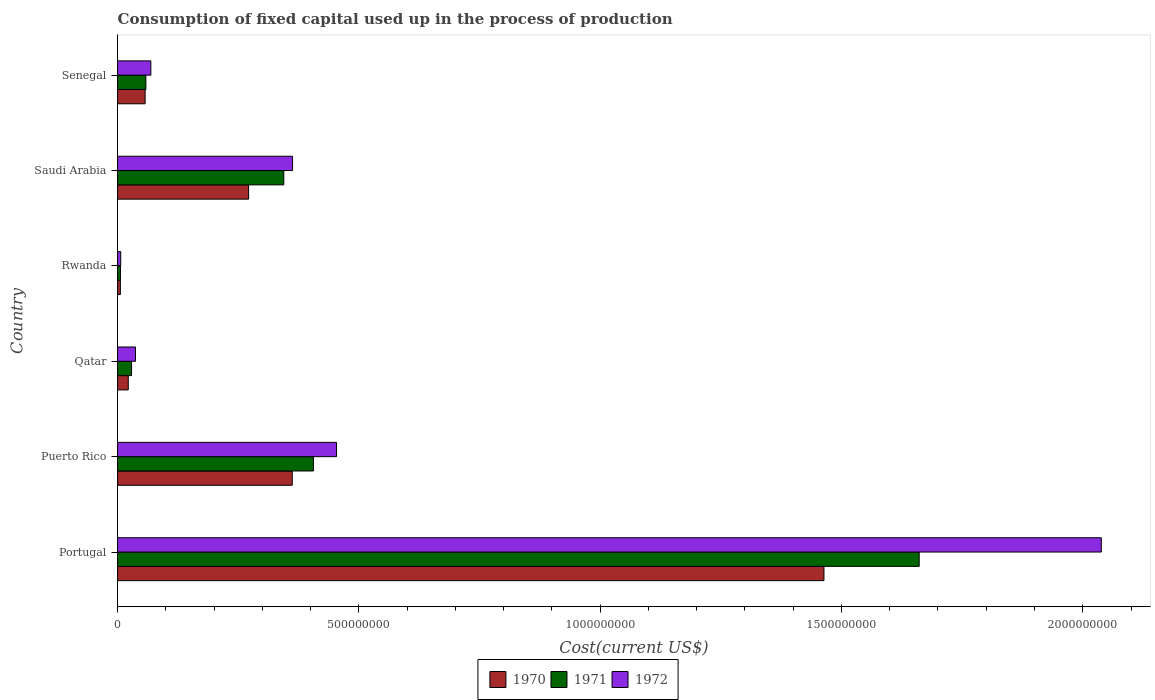Are the number of bars per tick equal to the number of legend labels?
Ensure brevity in your answer.  Yes. Are the number of bars on each tick of the Y-axis equal?
Offer a terse response. Yes. How many bars are there on the 5th tick from the bottom?
Provide a succinct answer. 3. What is the amount consumed in the process of production in 1970 in Rwanda?
Provide a short and direct response. 5.84e+06. Across all countries, what is the maximum amount consumed in the process of production in 1972?
Make the answer very short. 2.04e+09. Across all countries, what is the minimum amount consumed in the process of production in 1970?
Your response must be concise. 5.84e+06. In which country was the amount consumed in the process of production in 1971 maximum?
Your answer should be very brief. Portugal. In which country was the amount consumed in the process of production in 1972 minimum?
Provide a short and direct response. Rwanda. What is the total amount consumed in the process of production in 1971 in the graph?
Your answer should be very brief. 2.51e+09. What is the difference between the amount consumed in the process of production in 1971 in Puerto Rico and that in Qatar?
Make the answer very short. 3.77e+08. What is the difference between the amount consumed in the process of production in 1971 in Saudi Arabia and the amount consumed in the process of production in 1970 in Puerto Rico?
Offer a terse response. -1.75e+07. What is the average amount consumed in the process of production in 1972 per country?
Your answer should be compact. 4.95e+08. What is the difference between the amount consumed in the process of production in 1971 and amount consumed in the process of production in 1972 in Rwanda?
Keep it short and to the point. -5.68e+05. What is the ratio of the amount consumed in the process of production in 1971 in Saudi Arabia to that in Senegal?
Give a very brief answer. 5.87. What is the difference between the highest and the second highest amount consumed in the process of production in 1971?
Offer a terse response. 1.26e+09. What is the difference between the highest and the lowest amount consumed in the process of production in 1971?
Your answer should be compact. 1.66e+09. What does the 1st bar from the top in Qatar represents?
Make the answer very short. 1972. What does the 2nd bar from the bottom in Puerto Rico represents?
Your response must be concise. 1971. How many bars are there?
Provide a succinct answer. 18. How many countries are there in the graph?
Make the answer very short. 6. Are the values on the major ticks of X-axis written in scientific E-notation?
Your response must be concise. No. Does the graph contain grids?
Your response must be concise. No. How many legend labels are there?
Your answer should be compact. 3. What is the title of the graph?
Make the answer very short. Consumption of fixed capital used up in the process of production. Does "1972" appear as one of the legend labels in the graph?
Offer a very short reply. Yes. What is the label or title of the X-axis?
Ensure brevity in your answer.  Cost(current US$). What is the label or title of the Y-axis?
Your answer should be very brief. Country. What is the Cost(current US$) of 1970 in Portugal?
Offer a very short reply. 1.46e+09. What is the Cost(current US$) of 1971 in Portugal?
Your answer should be very brief. 1.66e+09. What is the Cost(current US$) in 1972 in Portugal?
Make the answer very short. 2.04e+09. What is the Cost(current US$) in 1970 in Puerto Rico?
Make the answer very short. 3.62e+08. What is the Cost(current US$) in 1971 in Puerto Rico?
Provide a succinct answer. 4.06e+08. What is the Cost(current US$) in 1972 in Puerto Rico?
Keep it short and to the point. 4.54e+08. What is the Cost(current US$) of 1970 in Qatar?
Ensure brevity in your answer.  2.22e+07. What is the Cost(current US$) in 1971 in Qatar?
Your response must be concise. 2.90e+07. What is the Cost(current US$) of 1972 in Qatar?
Provide a succinct answer. 3.72e+07. What is the Cost(current US$) of 1970 in Rwanda?
Your response must be concise. 5.84e+06. What is the Cost(current US$) of 1971 in Rwanda?
Your answer should be very brief. 5.99e+06. What is the Cost(current US$) of 1972 in Rwanda?
Provide a succinct answer. 6.56e+06. What is the Cost(current US$) in 1970 in Saudi Arabia?
Ensure brevity in your answer.  2.72e+08. What is the Cost(current US$) of 1971 in Saudi Arabia?
Offer a terse response. 3.44e+08. What is the Cost(current US$) in 1972 in Saudi Arabia?
Your answer should be compact. 3.63e+08. What is the Cost(current US$) in 1970 in Senegal?
Keep it short and to the point. 5.71e+07. What is the Cost(current US$) in 1971 in Senegal?
Offer a very short reply. 5.87e+07. What is the Cost(current US$) in 1972 in Senegal?
Provide a short and direct response. 6.90e+07. Across all countries, what is the maximum Cost(current US$) in 1970?
Give a very brief answer. 1.46e+09. Across all countries, what is the maximum Cost(current US$) in 1971?
Offer a terse response. 1.66e+09. Across all countries, what is the maximum Cost(current US$) of 1972?
Provide a succinct answer. 2.04e+09. Across all countries, what is the minimum Cost(current US$) in 1970?
Your answer should be very brief. 5.84e+06. Across all countries, what is the minimum Cost(current US$) of 1971?
Give a very brief answer. 5.99e+06. Across all countries, what is the minimum Cost(current US$) of 1972?
Your answer should be compact. 6.56e+06. What is the total Cost(current US$) of 1970 in the graph?
Make the answer very short. 2.18e+09. What is the total Cost(current US$) of 1971 in the graph?
Provide a succinct answer. 2.51e+09. What is the total Cost(current US$) of 1972 in the graph?
Provide a succinct answer. 2.97e+09. What is the difference between the Cost(current US$) in 1970 in Portugal and that in Puerto Rico?
Make the answer very short. 1.10e+09. What is the difference between the Cost(current US$) of 1971 in Portugal and that in Puerto Rico?
Keep it short and to the point. 1.26e+09. What is the difference between the Cost(current US$) of 1972 in Portugal and that in Puerto Rico?
Provide a succinct answer. 1.58e+09. What is the difference between the Cost(current US$) in 1970 in Portugal and that in Qatar?
Offer a terse response. 1.44e+09. What is the difference between the Cost(current US$) of 1971 in Portugal and that in Qatar?
Give a very brief answer. 1.63e+09. What is the difference between the Cost(current US$) of 1972 in Portugal and that in Qatar?
Offer a terse response. 2.00e+09. What is the difference between the Cost(current US$) in 1970 in Portugal and that in Rwanda?
Offer a terse response. 1.46e+09. What is the difference between the Cost(current US$) in 1971 in Portugal and that in Rwanda?
Provide a succinct answer. 1.66e+09. What is the difference between the Cost(current US$) of 1972 in Portugal and that in Rwanda?
Your response must be concise. 2.03e+09. What is the difference between the Cost(current US$) in 1970 in Portugal and that in Saudi Arabia?
Your response must be concise. 1.19e+09. What is the difference between the Cost(current US$) in 1971 in Portugal and that in Saudi Arabia?
Keep it short and to the point. 1.32e+09. What is the difference between the Cost(current US$) of 1972 in Portugal and that in Saudi Arabia?
Keep it short and to the point. 1.68e+09. What is the difference between the Cost(current US$) in 1970 in Portugal and that in Senegal?
Keep it short and to the point. 1.41e+09. What is the difference between the Cost(current US$) of 1971 in Portugal and that in Senegal?
Offer a very short reply. 1.60e+09. What is the difference between the Cost(current US$) of 1972 in Portugal and that in Senegal?
Keep it short and to the point. 1.97e+09. What is the difference between the Cost(current US$) of 1970 in Puerto Rico and that in Qatar?
Your answer should be very brief. 3.40e+08. What is the difference between the Cost(current US$) in 1971 in Puerto Rico and that in Qatar?
Provide a short and direct response. 3.77e+08. What is the difference between the Cost(current US$) in 1972 in Puerto Rico and that in Qatar?
Offer a terse response. 4.17e+08. What is the difference between the Cost(current US$) in 1970 in Puerto Rico and that in Rwanda?
Give a very brief answer. 3.56e+08. What is the difference between the Cost(current US$) in 1971 in Puerto Rico and that in Rwanda?
Ensure brevity in your answer.  4.00e+08. What is the difference between the Cost(current US$) of 1972 in Puerto Rico and that in Rwanda?
Keep it short and to the point. 4.47e+08. What is the difference between the Cost(current US$) of 1970 in Puerto Rico and that in Saudi Arabia?
Offer a very short reply. 9.04e+07. What is the difference between the Cost(current US$) of 1971 in Puerto Rico and that in Saudi Arabia?
Provide a short and direct response. 6.15e+07. What is the difference between the Cost(current US$) in 1972 in Puerto Rico and that in Saudi Arabia?
Provide a short and direct response. 9.11e+07. What is the difference between the Cost(current US$) of 1970 in Puerto Rico and that in Senegal?
Provide a succinct answer. 3.05e+08. What is the difference between the Cost(current US$) in 1971 in Puerto Rico and that in Senegal?
Offer a terse response. 3.47e+08. What is the difference between the Cost(current US$) in 1972 in Puerto Rico and that in Senegal?
Provide a succinct answer. 3.85e+08. What is the difference between the Cost(current US$) in 1970 in Qatar and that in Rwanda?
Provide a short and direct response. 1.63e+07. What is the difference between the Cost(current US$) in 1971 in Qatar and that in Rwanda?
Provide a succinct answer. 2.30e+07. What is the difference between the Cost(current US$) in 1972 in Qatar and that in Rwanda?
Ensure brevity in your answer.  3.06e+07. What is the difference between the Cost(current US$) in 1970 in Qatar and that in Saudi Arabia?
Make the answer very short. -2.49e+08. What is the difference between the Cost(current US$) of 1971 in Qatar and that in Saudi Arabia?
Your answer should be very brief. -3.15e+08. What is the difference between the Cost(current US$) of 1972 in Qatar and that in Saudi Arabia?
Provide a succinct answer. -3.25e+08. What is the difference between the Cost(current US$) in 1970 in Qatar and that in Senegal?
Make the answer very short. -3.50e+07. What is the difference between the Cost(current US$) of 1971 in Qatar and that in Senegal?
Your answer should be compact. -2.97e+07. What is the difference between the Cost(current US$) in 1972 in Qatar and that in Senegal?
Ensure brevity in your answer.  -3.18e+07. What is the difference between the Cost(current US$) in 1970 in Rwanda and that in Saudi Arabia?
Provide a succinct answer. -2.66e+08. What is the difference between the Cost(current US$) in 1971 in Rwanda and that in Saudi Arabia?
Make the answer very short. -3.38e+08. What is the difference between the Cost(current US$) of 1972 in Rwanda and that in Saudi Arabia?
Ensure brevity in your answer.  -3.56e+08. What is the difference between the Cost(current US$) in 1970 in Rwanda and that in Senegal?
Provide a succinct answer. -5.13e+07. What is the difference between the Cost(current US$) of 1971 in Rwanda and that in Senegal?
Make the answer very short. -5.27e+07. What is the difference between the Cost(current US$) in 1972 in Rwanda and that in Senegal?
Your response must be concise. -6.24e+07. What is the difference between the Cost(current US$) in 1970 in Saudi Arabia and that in Senegal?
Provide a short and direct response. 2.14e+08. What is the difference between the Cost(current US$) in 1971 in Saudi Arabia and that in Senegal?
Offer a terse response. 2.86e+08. What is the difference between the Cost(current US$) in 1972 in Saudi Arabia and that in Senegal?
Offer a very short reply. 2.94e+08. What is the difference between the Cost(current US$) of 1970 in Portugal and the Cost(current US$) of 1971 in Puerto Rico?
Make the answer very short. 1.06e+09. What is the difference between the Cost(current US$) in 1970 in Portugal and the Cost(current US$) in 1972 in Puerto Rico?
Provide a succinct answer. 1.01e+09. What is the difference between the Cost(current US$) of 1971 in Portugal and the Cost(current US$) of 1972 in Puerto Rico?
Your answer should be very brief. 1.21e+09. What is the difference between the Cost(current US$) of 1970 in Portugal and the Cost(current US$) of 1971 in Qatar?
Your answer should be very brief. 1.43e+09. What is the difference between the Cost(current US$) of 1970 in Portugal and the Cost(current US$) of 1972 in Qatar?
Your response must be concise. 1.43e+09. What is the difference between the Cost(current US$) in 1971 in Portugal and the Cost(current US$) in 1972 in Qatar?
Provide a succinct answer. 1.62e+09. What is the difference between the Cost(current US$) of 1970 in Portugal and the Cost(current US$) of 1971 in Rwanda?
Your answer should be compact. 1.46e+09. What is the difference between the Cost(current US$) in 1970 in Portugal and the Cost(current US$) in 1972 in Rwanda?
Offer a terse response. 1.46e+09. What is the difference between the Cost(current US$) in 1971 in Portugal and the Cost(current US$) in 1972 in Rwanda?
Offer a terse response. 1.65e+09. What is the difference between the Cost(current US$) in 1970 in Portugal and the Cost(current US$) in 1971 in Saudi Arabia?
Your answer should be compact. 1.12e+09. What is the difference between the Cost(current US$) of 1970 in Portugal and the Cost(current US$) of 1972 in Saudi Arabia?
Offer a very short reply. 1.10e+09. What is the difference between the Cost(current US$) in 1971 in Portugal and the Cost(current US$) in 1972 in Saudi Arabia?
Make the answer very short. 1.30e+09. What is the difference between the Cost(current US$) of 1970 in Portugal and the Cost(current US$) of 1971 in Senegal?
Offer a very short reply. 1.41e+09. What is the difference between the Cost(current US$) in 1970 in Portugal and the Cost(current US$) in 1972 in Senegal?
Offer a terse response. 1.39e+09. What is the difference between the Cost(current US$) in 1971 in Portugal and the Cost(current US$) in 1972 in Senegal?
Your answer should be very brief. 1.59e+09. What is the difference between the Cost(current US$) of 1970 in Puerto Rico and the Cost(current US$) of 1971 in Qatar?
Offer a very short reply. 3.33e+08. What is the difference between the Cost(current US$) in 1970 in Puerto Rico and the Cost(current US$) in 1972 in Qatar?
Your answer should be very brief. 3.25e+08. What is the difference between the Cost(current US$) of 1971 in Puerto Rico and the Cost(current US$) of 1972 in Qatar?
Offer a terse response. 3.69e+08. What is the difference between the Cost(current US$) in 1970 in Puerto Rico and the Cost(current US$) in 1971 in Rwanda?
Offer a terse response. 3.56e+08. What is the difference between the Cost(current US$) of 1970 in Puerto Rico and the Cost(current US$) of 1972 in Rwanda?
Keep it short and to the point. 3.55e+08. What is the difference between the Cost(current US$) in 1971 in Puerto Rico and the Cost(current US$) in 1972 in Rwanda?
Give a very brief answer. 3.99e+08. What is the difference between the Cost(current US$) of 1970 in Puerto Rico and the Cost(current US$) of 1971 in Saudi Arabia?
Provide a succinct answer. 1.75e+07. What is the difference between the Cost(current US$) in 1970 in Puerto Rico and the Cost(current US$) in 1972 in Saudi Arabia?
Make the answer very short. -6.36e+05. What is the difference between the Cost(current US$) of 1971 in Puerto Rico and the Cost(current US$) of 1972 in Saudi Arabia?
Your response must be concise. 4.33e+07. What is the difference between the Cost(current US$) of 1970 in Puerto Rico and the Cost(current US$) of 1971 in Senegal?
Make the answer very short. 3.03e+08. What is the difference between the Cost(current US$) in 1970 in Puerto Rico and the Cost(current US$) in 1972 in Senegal?
Your answer should be very brief. 2.93e+08. What is the difference between the Cost(current US$) of 1971 in Puerto Rico and the Cost(current US$) of 1972 in Senegal?
Keep it short and to the point. 3.37e+08. What is the difference between the Cost(current US$) of 1970 in Qatar and the Cost(current US$) of 1971 in Rwanda?
Give a very brief answer. 1.62e+07. What is the difference between the Cost(current US$) of 1970 in Qatar and the Cost(current US$) of 1972 in Rwanda?
Offer a terse response. 1.56e+07. What is the difference between the Cost(current US$) in 1971 in Qatar and the Cost(current US$) in 1972 in Rwanda?
Make the answer very short. 2.24e+07. What is the difference between the Cost(current US$) in 1970 in Qatar and the Cost(current US$) in 1971 in Saudi Arabia?
Your answer should be very brief. -3.22e+08. What is the difference between the Cost(current US$) of 1970 in Qatar and the Cost(current US$) of 1972 in Saudi Arabia?
Offer a very short reply. -3.40e+08. What is the difference between the Cost(current US$) in 1971 in Qatar and the Cost(current US$) in 1972 in Saudi Arabia?
Make the answer very short. -3.34e+08. What is the difference between the Cost(current US$) in 1970 in Qatar and the Cost(current US$) in 1971 in Senegal?
Provide a short and direct response. -3.65e+07. What is the difference between the Cost(current US$) of 1970 in Qatar and the Cost(current US$) of 1972 in Senegal?
Your response must be concise. -4.68e+07. What is the difference between the Cost(current US$) in 1971 in Qatar and the Cost(current US$) in 1972 in Senegal?
Give a very brief answer. -4.00e+07. What is the difference between the Cost(current US$) of 1970 in Rwanda and the Cost(current US$) of 1971 in Saudi Arabia?
Make the answer very short. -3.39e+08. What is the difference between the Cost(current US$) in 1970 in Rwanda and the Cost(current US$) in 1972 in Saudi Arabia?
Provide a short and direct response. -3.57e+08. What is the difference between the Cost(current US$) in 1971 in Rwanda and the Cost(current US$) in 1972 in Saudi Arabia?
Your answer should be very brief. -3.57e+08. What is the difference between the Cost(current US$) of 1970 in Rwanda and the Cost(current US$) of 1971 in Senegal?
Give a very brief answer. -5.29e+07. What is the difference between the Cost(current US$) in 1970 in Rwanda and the Cost(current US$) in 1972 in Senegal?
Your answer should be compact. -6.31e+07. What is the difference between the Cost(current US$) of 1971 in Rwanda and the Cost(current US$) of 1972 in Senegal?
Provide a succinct answer. -6.30e+07. What is the difference between the Cost(current US$) in 1970 in Saudi Arabia and the Cost(current US$) in 1971 in Senegal?
Give a very brief answer. 2.13e+08. What is the difference between the Cost(current US$) of 1970 in Saudi Arabia and the Cost(current US$) of 1972 in Senegal?
Ensure brevity in your answer.  2.03e+08. What is the difference between the Cost(current US$) in 1971 in Saudi Arabia and the Cost(current US$) in 1972 in Senegal?
Offer a terse response. 2.75e+08. What is the average Cost(current US$) of 1970 per country?
Your response must be concise. 3.64e+08. What is the average Cost(current US$) in 1971 per country?
Your response must be concise. 4.18e+08. What is the average Cost(current US$) in 1972 per country?
Ensure brevity in your answer.  4.95e+08. What is the difference between the Cost(current US$) in 1970 and Cost(current US$) in 1971 in Portugal?
Your response must be concise. -1.97e+08. What is the difference between the Cost(current US$) of 1970 and Cost(current US$) of 1972 in Portugal?
Provide a short and direct response. -5.75e+08. What is the difference between the Cost(current US$) in 1971 and Cost(current US$) in 1972 in Portugal?
Provide a short and direct response. -3.77e+08. What is the difference between the Cost(current US$) in 1970 and Cost(current US$) in 1971 in Puerto Rico?
Make the answer very short. -4.40e+07. What is the difference between the Cost(current US$) of 1970 and Cost(current US$) of 1972 in Puerto Rico?
Make the answer very short. -9.18e+07. What is the difference between the Cost(current US$) in 1971 and Cost(current US$) in 1972 in Puerto Rico?
Your answer should be compact. -4.78e+07. What is the difference between the Cost(current US$) of 1970 and Cost(current US$) of 1971 in Qatar?
Keep it short and to the point. -6.81e+06. What is the difference between the Cost(current US$) in 1970 and Cost(current US$) in 1972 in Qatar?
Your response must be concise. -1.50e+07. What is the difference between the Cost(current US$) of 1971 and Cost(current US$) of 1972 in Qatar?
Provide a short and direct response. -8.20e+06. What is the difference between the Cost(current US$) of 1970 and Cost(current US$) of 1971 in Rwanda?
Make the answer very short. -1.47e+05. What is the difference between the Cost(current US$) in 1970 and Cost(current US$) in 1972 in Rwanda?
Your answer should be very brief. -7.15e+05. What is the difference between the Cost(current US$) in 1971 and Cost(current US$) in 1972 in Rwanda?
Provide a short and direct response. -5.68e+05. What is the difference between the Cost(current US$) in 1970 and Cost(current US$) in 1971 in Saudi Arabia?
Provide a succinct answer. -7.29e+07. What is the difference between the Cost(current US$) in 1970 and Cost(current US$) in 1972 in Saudi Arabia?
Your answer should be compact. -9.11e+07. What is the difference between the Cost(current US$) of 1971 and Cost(current US$) of 1972 in Saudi Arabia?
Offer a very short reply. -1.81e+07. What is the difference between the Cost(current US$) of 1970 and Cost(current US$) of 1971 in Senegal?
Keep it short and to the point. -1.55e+06. What is the difference between the Cost(current US$) of 1970 and Cost(current US$) of 1972 in Senegal?
Offer a very short reply. -1.18e+07. What is the difference between the Cost(current US$) in 1971 and Cost(current US$) in 1972 in Senegal?
Keep it short and to the point. -1.03e+07. What is the ratio of the Cost(current US$) of 1970 in Portugal to that in Puerto Rico?
Your response must be concise. 4.04. What is the ratio of the Cost(current US$) in 1971 in Portugal to that in Puerto Rico?
Give a very brief answer. 4.09. What is the ratio of the Cost(current US$) in 1972 in Portugal to that in Puerto Rico?
Offer a very short reply. 4.49. What is the ratio of the Cost(current US$) of 1970 in Portugal to that in Qatar?
Offer a terse response. 65.97. What is the ratio of the Cost(current US$) of 1971 in Portugal to that in Qatar?
Your answer should be very brief. 57.29. What is the ratio of the Cost(current US$) of 1972 in Portugal to that in Qatar?
Provide a succinct answer. 54.81. What is the ratio of the Cost(current US$) of 1970 in Portugal to that in Rwanda?
Keep it short and to the point. 250.6. What is the ratio of the Cost(current US$) of 1971 in Portugal to that in Rwanda?
Make the answer very short. 277.38. What is the ratio of the Cost(current US$) of 1972 in Portugal to that in Rwanda?
Give a very brief answer. 310.91. What is the ratio of the Cost(current US$) of 1970 in Portugal to that in Saudi Arabia?
Ensure brevity in your answer.  5.39. What is the ratio of the Cost(current US$) of 1971 in Portugal to that in Saudi Arabia?
Your answer should be very brief. 4.82. What is the ratio of the Cost(current US$) in 1972 in Portugal to that in Saudi Arabia?
Offer a very short reply. 5.62. What is the ratio of the Cost(current US$) of 1970 in Portugal to that in Senegal?
Provide a succinct answer. 25.62. What is the ratio of the Cost(current US$) of 1971 in Portugal to that in Senegal?
Provide a succinct answer. 28.3. What is the ratio of the Cost(current US$) in 1972 in Portugal to that in Senegal?
Your response must be concise. 29.55. What is the ratio of the Cost(current US$) of 1970 in Puerto Rico to that in Qatar?
Provide a succinct answer. 16.31. What is the ratio of the Cost(current US$) in 1971 in Puerto Rico to that in Qatar?
Your response must be concise. 14. What is the ratio of the Cost(current US$) of 1972 in Puerto Rico to that in Qatar?
Your response must be concise. 12.2. What is the ratio of the Cost(current US$) in 1970 in Puerto Rico to that in Rwanda?
Ensure brevity in your answer.  61.97. What is the ratio of the Cost(current US$) of 1971 in Puerto Rico to that in Rwanda?
Offer a very short reply. 67.79. What is the ratio of the Cost(current US$) in 1972 in Puerto Rico to that in Rwanda?
Your answer should be compact. 69.21. What is the ratio of the Cost(current US$) of 1970 in Puerto Rico to that in Saudi Arabia?
Give a very brief answer. 1.33. What is the ratio of the Cost(current US$) of 1971 in Puerto Rico to that in Saudi Arabia?
Provide a short and direct response. 1.18. What is the ratio of the Cost(current US$) of 1972 in Puerto Rico to that in Saudi Arabia?
Keep it short and to the point. 1.25. What is the ratio of the Cost(current US$) of 1970 in Puerto Rico to that in Senegal?
Your answer should be compact. 6.34. What is the ratio of the Cost(current US$) of 1971 in Puerto Rico to that in Senegal?
Ensure brevity in your answer.  6.92. What is the ratio of the Cost(current US$) of 1972 in Puerto Rico to that in Senegal?
Your response must be concise. 6.58. What is the ratio of the Cost(current US$) in 1970 in Qatar to that in Rwanda?
Your answer should be very brief. 3.8. What is the ratio of the Cost(current US$) of 1971 in Qatar to that in Rwanda?
Provide a succinct answer. 4.84. What is the ratio of the Cost(current US$) in 1972 in Qatar to that in Rwanda?
Your response must be concise. 5.67. What is the ratio of the Cost(current US$) of 1970 in Qatar to that in Saudi Arabia?
Ensure brevity in your answer.  0.08. What is the ratio of the Cost(current US$) in 1971 in Qatar to that in Saudi Arabia?
Give a very brief answer. 0.08. What is the ratio of the Cost(current US$) in 1972 in Qatar to that in Saudi Arabia?
Provide a succinct answer. 0.1. What is the ratio of the Cost(current US$) of 1970 in Qatar to that in Senegal?
Ensure brevity in your answer.  0.39. What is the ratio of the Cost(current US$) of 1971 in Qatar to that in Senegal?
Provide a short and direct response. 0.49. What is the ratio of the Cost(current US$) in 1972 in Qatar to that in Senegal?
Your answer should be very brief. 0.54. What is the ratio of the Cost(current US$) in 1970 in Rwanda to that in Saudi Arabia?
Your answer should be very brief. 0.02. What is the ratio of the Cost(current US$) in 1971 in Rwanda to that in Saudi Arabia?
Your answer should be very brief. 0.02. What is the ratio of the Cost(current US$) of 1972 in Rwanda to that in Saudi Arabia?
Provide a succinct answer. 0.02. What is the ratio of the Cost(current US$) of 1970 in Rwanda to that in Senegal?
Provide a succinct answer. 0.1. What is the ratio of the Cost(current US$) of 1971 in Rwanda to that in Senegal?
Your answer should be very brief. 0.1. What is the ratio of the Cost(current US$) of 1972 in Rwanda to that in Senegal?
Provide a short and direct response. 0.1. What is the ratio of the Cost(current US$) in 1970 in Saudi Arabia to that in Senegal?
Provide a succinct answer. 4.75. What is the ratio of the Cost(current US$) of 1971 in Saudi Arabia to that in Senegal?
Offer a very short reply. 5.87. What is the ratio of the Cost(current US$) in 1972 in Saudi Arabia to that in Senegal?
Offer a terse response. 5.26. What is the difference between the highest and the second highest Cost(current US$) of 1970?
Make the answer very short. 1.10e+09. What is the difference between the highest and the second highest Cost(current US$) of 1971?
Provide a succinct answer. 1.26e+09. What is the difference between the highest and the second highest Cost(current US$) of 1972?
Give a very brief answer. 1.58e+09. What is the difference between the highest and the lowest Cost(current US$) of 1970?
Keep it short and to the point. 1.46e+09. What is the difference between the highest and the lowest Cost(current US$) of 1971?
Your response must be concise. 1.66e+09. What is the difference between the highest and the lowest Cost(current US$) of 1972?
Your response must be concise. 2.03e+09. 